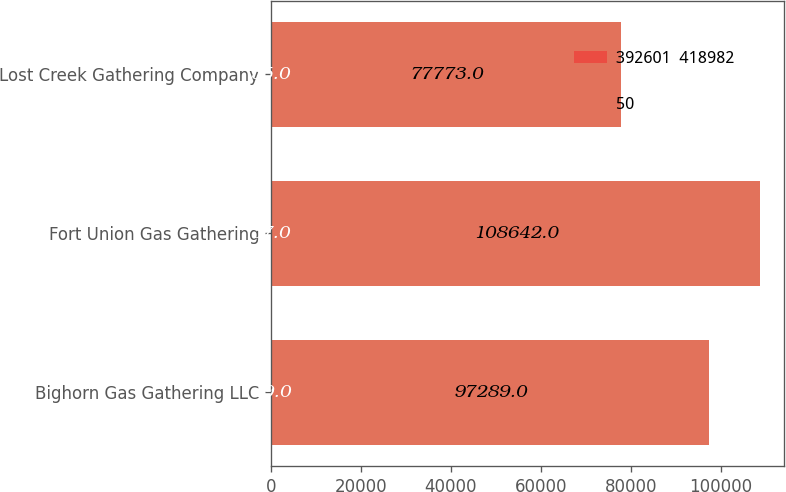Convert chart. <chart><loc_0><loc_0><loc_500><loc_500><stacked_bar_chart><ecel><fcel>Bighorn Gas Gathering LLC<fcel>Fort Union Gas Gathering<fcel>Lost Creek Gathering Company<nl><fcel>392601  418982<fcel>49<fcel>37<fcel>35<nl><fcel>50<fcel>97289<fcel>108642<fcel>77773<nl></chart> 